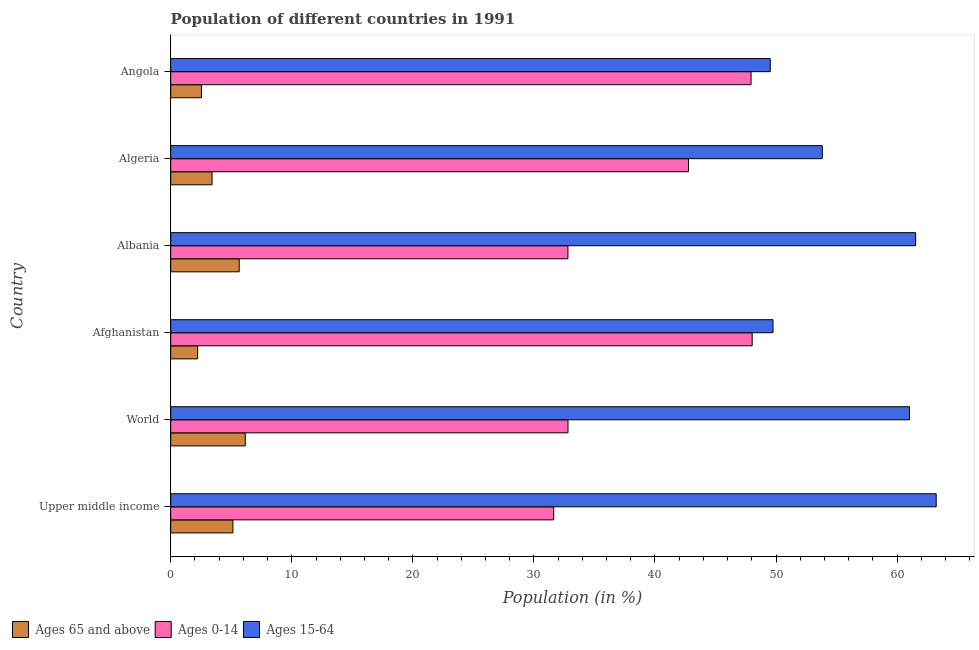How many groups of bars are there?
Provide a succinct answer. 6. Are the number of bars per tick equal to the number of legend labels?
Make the answer very short. Yes. Are the number of bars on each tick of the Y-axis equal?
Provide a succinct answer. Yes. How many bars are there on the 6th tick from the top?
Offer a very short reply. 3. How many bars are there on the 1st tick from the bottom?
Your answer should be very brief. 3. What is the label of the 2nd group of bars from the top?
Provide a succinct answer. Algeria. In how many cases, is the number of bars for a given country not equal to the number of legend labels?
Ensure brevity in your answer.  0. What is the percentage of population within the age-group 15-64 in Upper middle income?
Make the answer very short. 63.23. Across all countries, what is the maximum percentage of population within the age-group of 65 and above?
Ensure brevity in your answer.  6.16. Across all countries, what is the minimum percentage of population within the age-group 0-14?
Offer a very short reply. 31.63. In which country was the percentage of population within the age-group 15-64 maximum?
Offer a very short reply. Upper middle income. In which country was the percentage of population within the age-group 15-64 minimum?
Your answer should be compact. Angola. What is the total percentage of population within the age-group of 65 and above in the graph?
Give a very brief answer. 25.13. What is the difference between the percentage of population within the age-group 0-14 in Albania and that in Algeria?
Provide a succinct answer. -9.96. What is the difference between the percentage of population within the age-group of 65 and above in Angola and the percentage of population within the age-group 0-14 in Algeria?
Keep it short and to the point. -40.23. What is the average percentage of population within the age-group of 65 and above per country?
Keep it short and to the point. 4.19. What is the difference between the percentage of population within the age-group 0-14 and percentage of population within the age-group of 65 and above in Angola?
Offer a very short reply. 45.4. What is the ratio of the percentage of population within the age-group of 65 and above in Algeria to that in Angola?
Offer a terse response. 1.34. Is the percentage of population within the age-group 15-64 in Algeria less than that in Angola?
Offer a terse response. No. What is the difference between the highest and the second highest percentage of population within the age-group 0-14?
Offer a terse response. 0.09. What is the difference between the highest and the lowest percentage of population within the age-group 15-64?
Your answer should be very brief. 13.71. What does the 3rd bar from the top in Upper middle income represents?
Keep it short and to the point. Ages 65 and above. What does the 1st bar from the bottom in Upper middle income represents?
Provide a succinct answer. Ages 65 and above. How many bars are there?
Make the answer very short. 18. Are all the bars in the graph horizontal?
Your response must be concise. Yes. Are the values on the major ticks of X-axis written in scientific E-notation?
Provide a succinct answer. No. Does the graph contain any zero values?
Give a very brief answer. No. Does the graph contain grids?
Provide a succinct answer. No. How many legend labels are there?
Make the answer very short. 3. How are the legend labels stacked?
Your answer should be compact. Horizontal. What is the title of the graph?
Offer a very short reply. Population of different countries in 1991. What is the label or title of the X-axis?
Your answer should be compact. Population (in %). What is the Population (in %) in Ages 65 and above in Upper middle income?
Make the answer very short. 5.14. What is the Population (in %) in Ages 0-14 in Upper middle income?
Provide a short and direct response. 31.63. What is the Population (in %) in Ages 15-64 in Upper middle income?
Give a very brief answer. 63.23. What is the Population (in %) of Ages 65 and above in World?
Keep it short and to the point. 6.16. What is the Population (in %) of Ages 0-14 in World?
Offer a very short reply. 32.82. What is the Population (in %) of Ages 15-64 in World?
Your answer should be compact. 61.03. What is the Population (in %) of Ages 65 and above in Afghanistan?
Provide a succinct answer. 2.22. What is the Population (in %) of Ages 0-14 in Afghanistan?
Your response must be concise. 48.03. What is the Population (in %) in Ages 15-64 in Afghanistan?
Keep it short and to the point. 49.75. What is the Population (in %) of Ages 65 and above in Albania?
Offer a very short reply. 5.66. What is the Population (in %) in Ages 0-14 in Albania?
Ensure brevity in your answer.  32.81. What is the Population (in %) in Ages 15-64 in Albania?
Offer a very short reply. 61.53. What is the Population (in %) in Ages 65 and above in Algeria?
Provide a succinct answer. 3.41. What is the Population (in %) of Ages 0-14 in Algeria?
Ensure brevity in your answer.  42.77. What is the Population (in %) in Ages 15-64 in Algeria?
Offer a terse response. 53.82. What is the Population (in %) of Ages 65 and above in Angola?
Keep it short and to the point. 2.54. What is the Population (in %) of Ages 0-14 in Angola?
Give a very brief answer. 47.94. What is the Population (in %) in Ages 15-64 in Angola?
Ensure brevity in your answer.  49.52. Across all countries, what is the maximum Population (in %) of Ages 65 and above?
Offer a very short reply. 6.16. Across all countries, what is the maximum Population (in %) of Ages 0-14?
Offer a very short reply. 48.03. Across all countries, what is the maximum Population (in %) in Ages 15-64?
Your answer should be compact. 63.23. Across all countries, what is the minimum Population (in %) of Ages 65 and above?
Your response must be concise. 2.22. Across all countries, what is the minimum Population (in %) of Ages 0-14?
Keep it short and to the point. 31.63. Across all countries, what is the minimum Population (in %) of Ages 15-64?
Provide a succinct answer. 49.52. What is the total Population (in %) in Ages 65 and above in the graph?
Ensure brevity in your answer.  25.12. What is the total Population (in %) of Ages 0-14 in the graph?
Provide a short and direct response. 236. What is the total Population (in %) in Ages 15-64 in the graph?
Your answer should be very brief. 338.88. What is the difference between the Population (in %) in Ages 65 and above in Upper middle income and that in World?
Provide a short and direct response. -1.02. What is the difference between the Population (in %) in Ages 0-14 in Upper middle income and that in World?
Your answer should be very brief. -1.18. What is the difference between the Population (in %) of Ages 15-64 in Upper middle income and that in World?
Keep it short and to the point. 2.21. What is the difference between the Population (in %) in Ages 65 and above in Upper middle income and that in Afghanistan?
Give a very brief answer. 2.91. What is the difference between the Population (in %) of Ages 0-14 in Upper middle income and that in Afghanistan?
Your answer should be compact. -16.4. What is the difference between the Population (in %) of Ages 15-64 in Upper middle income and that in Afghanistan?
Ensure brevity in your answer.  13.48. What is the difference between the Population (in %) of Ages 65 and above in Upper middle income and that in Albania?
Provide a short and direct response. -0.52. What is the difference between the Population (in %) of Ages 0-14 in Upper middle income and that in Albania?
Keep it short and to the point. -1.18. What is the difference between the Population (in %) of Ages 15-64 in Upper middle income and that in Albania?
Ensure brevity in your answer.  1.7. What is the difference between the Population (in %) of Ages 65 and above in Upper middle income and that in Algeria?
Offer a very short reply. 1.72. What is the difference between the Population (in %) of Ages 0-14 in Upper middle income and that in Algeria?
Your answer should be compact. -11.13. What is the difference between the Population (in %) in Ages 15-64 in Upper middle income and that in Algeria?
Keep it short and to the point. 9.41. What is the difference between the Population (in %) of Ages 65 and above in Upper middle income and that in Angola?
Ensure brevity in your answer.  2.6. What is the difference between the Population (in %) of Ages 0-14 in Upper middle income and that in Angola?
Your answer should be compact. -16.3. What is the difference between the Population (in %) of Ages 15-64 in Upper middle income and that in Angola?
Your answer should be very brief. 13.71. What is the difference between the Population (in %) in Ages 65 and above in World and that in Afghanistan?
Your answer should be compact. 3.94. What is the difference between the Population (in %) in Ages 0-14 in World and that in Afghanistan?
Offer a terse response. -15.21. What is the difference between the Population (in %) of Ages 15-64 in World and that in Afghanistan?
Provide a short and direct response. 11.28. What is the difference between the Population (in %) of Ages 65 and above in World and that in Albania?
Your response must be concise. 0.5. What is the difference between the Population (in %) in Ages 0-14 in World and that in Albania?
Your answer should be very brief. 0. What is the difference between the Population (in %) in Ages 15-64 in World and that in Albania?
Your response must be concise. -0.51. What is the difference between the Population (in %) of Ages 65 and above in World and that in Algeria?
Make the answer very short. 2.74. What is the difference between the Population (in %) in Ages 0-14 in World and that in Algeria?
Ensure brevity in your answer.  -9.95. What is the difference between the Population (in %) of Ages 15-64 in World and that in Algeria?
Provide a succinct answer. 7.21. What is the difference between the Population (in %) of Ages 65 and above in World and that in Angola?
Keep it short and to the point. 3.62. What is the difference between the Population (in %) of Ages 0-14 in World and that in Angola?
Your answer should be compact. -15.12. What is the difference between the Population (in %) in Ages 15-64 in World and that in Angola?
Your answer should be very brief. 11.5. What is the difference between the Population (in %) of Ages 65 and above in Afghanistan and that in Albania?
Provide a succinct answer. -3.44. What is the difference between the Population (in %) in Ages 0-14 in Afghanistan and that in Albania?
Give a very brief answer. 15.22. What is the difference between the Population (in %) of Ages 15-64 in Afghanistan and that in Albania?
Your response must be concise. -11.78. What is the difference between the Population (in %) of Ages 65 and above in Afghanistan and that in Algeria?
Offer a very short reply. -1.19. What is the difference between the Population (in %) in Ages 0-14 in Afghanistan and that in Algeria?
Make the answer very short. 5.26. What is the difference between the Population (in %) of Ages 15-64 in Afghanistan and that in Algeria?
Make the answer very short. -4.07. What is the difference between the Population (in %) of Ages 65 and above in Afghanistan and that in Angola?
Your answer should be compact. -0.32. What is the difference between the Population (in %) in Ages 0-14 in Afghanistan and that in Angola?
Your answer should be very brief. 0.09. What is the difference between the Population (in %) of Ages 15-64 in Afghanistan and that in Angola?
Ensure brevity in your answer.  0.23. What is the difference between the Population (in %) of Ages 65 and above in Albania and that in Algeria?
Provide a succinct answer. 2.24. What is the difference between the Population (in %) of Ages 0-14 in Albania and that in Algeria?
Make the answer very short. -9.95. What is the difference between the Population (in %) of Ages 15-64 in Albania and that in Algeria?
Your answer should be compact. 7.71. What is the difference between the Population (in %) of Ages 65 and above in Albania and that in Angola?
Keep it short and to the point. 3.12. What is the difference between the Population (in %) of Ages 0-14 in Albania and that in Angola?
Provide a succinct answer. -15.13. What is the difference between the Population (in %) of Ages 15-64 in Albania and that in Angola?
Provide a succinct answer. 12.01. What is the difference between the Population (in %) of Ages 65 and above in Algeria and that in Angola?
Offer a terse response. 0.88. What is the difference between the Population (in %) in Ages 0-14 in Algeria and that in Angola?
Provide a short and direct response. -5.17. What is the difference between the Population (in %) in Ages 15-64 in Algeria and that in Angola?
Provide a succinct answer. 4.29. What is the difference between the Population (in %) in Ages 65 and above in Upper middle income and the Population (in %) in Ages 0-14 in World?
Offer a very short reply. -27.68. What is the difference between the Population (in %) in Ages 65 and above in Upper middle income and the Population (in %) in Ages 15-64 in World?
Offer a terse response. -55.89. What is the difference between the Population (in %) of Ages 0-14 in Upper middle income and the Population (in %) of Ages 15-64 in World?
Offer a terse response. -29.39. What is the difference between the Population (in %) in Ages 65 and above in Upper middle income and the Population (in %) in Ages 0-14 in Afghanistan?
Provide a succinct answer. -42.89. What is the difference between the Population (in %) in Ages 65 and above in Upper middle income and the Population (in %) in Ages 15-64 in Afghanistan?
Make the answer very short. -44.61. What is the difference between the Population (in %) of Ages 0-14 in Upper middle income and the Population (in %) of Ages 15-64 in Afghanistan?
Give a very brief answer. -18.12. What is the difference between the Population (in %) of Ages 65 and above in Upper middle income and the Population (in %) of Ages 0-14 in Albania?
Ensure brevity in your answer.  -27.68. What is the difference between the Population (in %) of Ages 65 and above in Upper middle income and the Population (in %) of Ages 15-64 in Albania?
Your answer should be very brief. -56.39. What is the difference between the Population (in %) of Ages 0-14 in Upper middle income and the Population (in %) of Ages 15-64 in Albania?
Your response must be concise. -29.9. What is the difference between the Population (in %) in Ages 65 and above in Upper middle income and the Population (in %) in Ages 0-14 in Algeria?
Your response must be concise. -37.63. What is the difference between the Population (in %) of Ages 65 and above in Upper middle income and the Population (in %) of Ages 15-64 in Algeria?
Provide a short and direct response. -48.68. What is the difference between the Population (in %) in Ages 0-14 in Upper middle income and the Population (in %) in Ages 15-64 in Algeria?
Give a very brief answer. -22.19. What is the difference between the Population (in %) in Ages 65 and above in Upper middle income and the Population (in %) in Ages 0-14 in Angola?
Provide a succinct answer. -42.8. What is the difference between the Population (in %) of Ages 65 and above in Upper middle income and the Population (in %) of Ages 15-64 in Angola?
Provide a short and direct response. -44.39. What is the difference between the Population (in %) of Ages 0-14 in Upper middle income and the Population (in %) of Ages 15-64 in Angola?
Keep it short and to the point. -17.89. What is the difference between the Population (in %) of Ages 65 and above in World and the Population (in %) of Ages 0-14 in Afghanistan?
Ensure brevity in your answer.  -41.87. What is the difference between the Population (in %) of Ages 65 and above in World and the Population (in %) of Ages 15-64 in Afghanistan?
Offer a terse response. -43.59. What is the difference between the Population (in %) in Ages 0-14 in World and the Population (in %) in Ages 15-64 in Afghanistan?
Your response must be concise. -16.93. What is the difference between the Population (in %) of Ages 65 and above in World and the Population (in %) of Ages 0-14 in Albania?
Your answer should be compact. -26.65. What is the difference between the Population (in %) in Ages 65 and above in World and the Population (in %) in Ages 15-64 in Albania?
Provide a short and direct response. -55.37. What is the difference between the Population (in %) in Ages 0-14 in World and the Population (in %) in Ages 15-64 in Albania?
Make the answer very short. -28.71. What is the difference between the Population (in %) of Ages 65 and above in World and the Population (in %) of Ages 0-14 in Algeria?
Your answer should be very brief. -36.61. What is the difference between the Population (in %) of Ages 65 and above in World and the Population (in %) of Ages 15-64 in Algeria?
Keep it short and to the point. -47.66. What is the difference between the Population (in %) of Ages 0-14 in World and the Population (in %) of Ages 15-64 in Algeria?
Your answer should be compact. -21. What is the difference between the Population (in %) of Ages 65 and above in World and the Population (in %) of Ages 0-14 in Angola?
Offer a terse response. -41.78. What is the difference between the Population (in %) in Ages 65 and above in World and the Population (in %) in Ages 15-64 in Angola?
Provide a succinct answer. -43.37. What is the difference between the Population (in %) in Ages 0-14 in World and the Population (in %) in Ages 15-64 in Angola?
Ensure brevity in your answer.  -16.71. What is the difference between the Population (in %) of Ages 65 and above in Afghanistan and the Population (in %) of Ages 0-14 in Albania?
Offer a very short reply. -30.59. What is the difference between the Population (in %) of Ages 65 and above in Afghanistan and the Population (in %) of Ages 15-64 in Albania?
Provide a short and direct response. -59.31. What is the difference between the Population (in %) in Ages 0-14 in Afghanistan and the Population (in %) in Ages 15-64 in Albania?
Your answer should be very brief. -13.5. What is the difference between the Population (in %) in Ages 65 and above in Afghanistan and the Population (in %) in Ages 0-14 in Algeria?
Keep it short and to the point. -40.55. What is the difference between the Population (in %) of Ages 65 and above in Afghanistan and the Population (in %) of Ages 15-64 in Algeria?
Make the answer very short. -51.6. What is the difference between the Population (in %) in Ages 0-14 in Afghanistan and the Population (in %) in Ages 15-64 in Algeria?
Provide a succinct answer. -5.79. What is the difference between the Population (in %) in Ages 65 and above in Afghanistan and the Population (in %) in Ages 0-14 in Angola?
Ensure brevity in your answer.  -45.72. What is the difference between the Population (in %) in Ages 65 and above in Afghanistan and the Population (in %) in Ages 15-64 in Angola?
Ensure brevity in your answer.  -47.3. What is the difference between the Population (in %) of Ages 0-14 in Afghanistan and the Population (in %) of Ages 15-64 in Angola?
Offer a very short reply. -1.49. What is the difference between the Population (in %) of Ages 65 and above in Albania and the Population (in %) of Ages 0-14 in Algeria?
Make the answer very short. -37.11. What is the difference between the Population (in %) of Ages 65 and above in Albania and the Population (in %) of Ages 15-64 in Algeria?
Offer a very short reply. -48.16. What is the difference between the Population (in %) in Ages 0-14 in Albania and the Population (in %) in Ages 15-64 in Algeria?
Your answer should be compact. -21.01. What is the difference between the Population (in %) of Ages 65 and above in Albania and the Population (in %) of Ages 0-14 in Angola?
Give a very brief answer. -42.28. What is the difference between the Population (in %) of Ages 65 and above in Albania and the Population (in %) of Ages 15-64 in Angola?
Offer a very short reply. -43.87. What is the difference between the Population (in %) of Ages 0-14 in Albania and the Population (in %) of Ages 15-64 in Angola?
Your answer should be compact. -16.71. What is the difference between the Population (in %) in Ages 65 and above in Algeria and the Population (in %) in Ages 0-14 in Angola?
Provide a short and direct response. -44.52. What is the difference between the Population (in %) of Ages 65 and above in Algeria and the Population (in %) of Ages 15-64 in Angola?
Make the answer very short. -46.11. What is the difference between the Population (in %) in Ages 0-14 in Algeria and the Population (in %) in Ages 15-64 in Angola?
Your answer should be compact. -6.76. What is the average Population (in %) of Ages 65 and above per country?
Provide a succinct answer. 4.19. What is the average Population (in %) in Ages 0-14 per country?
Give a very brief answer. 39.33. What is the average Population (in %) of Ages 15-64 per country?
Your answer should be very brief. 56.48. What is the difference between the Population (in %) of Ages 65 and above and Population (in %) of Ages 0-14 in Upper middle income?
Give a very brief answer. -26.5. What is the difference between the Population (in %) in Ages 65 and above and Population (in %) in Ages 15-64 in Upper middle income?
Offer a terse response. -58.09. What is the difference between the Population (in %) of Ages 0-14 and Population (in %) of Ages 15-64 in Upper middle income?
Offer a terse response. -31.6. What is the difference between the Population (in %) in Ages 65 and above and Population (in %) in Ages 0-14 in World?
Provide a succinct answer. -26.66. What is the difference between the Population (in %) in Ages 65 and above and Population (in %) in Ages 15-64 in World?
Ensure brevity in your answer.  -54.87. What is the difference between the Population (in %) of Ages 0-14 and Population (in %) of Ages 15-64 in World?
Your response must be concise. -28.21. What is the difference between the Population (in %) of Ages 65 and above and Population (in %) of Ages 0-14 in Afghanistan?
Offer a very short reply. -45.81. What is the difference between the Population (in %) of Ages 65 and above and Population (in %) of Ages 15-64 in Afghanistan?
Keep it short and to the point. -47.53. What is the difference between the Population (in %) in Ages 0-14 and Population (in %) in Ages 15-64 in Afghanistan?
Offer a terse response. -1.72. What is the difference between the Population (in %) of Ages 65 and above and Population (in %) of Ages 0-14 in Albania?
Offer a terse response. -27.16. What is the difference between the Population (in %) of Ages 65 and above and Population (in %) of Ages 15-64 in Albania?
Your answer should be compact. -55.87. What is the difference between the Population (in %) of Ages 0-14 and Population (in %) of Ages 15-64 in Albania?
Offer a terse response. -28.72. What is the difference between the Population (in %) in Ages 65 and above and Population (in %) in Ages 0-14 in Algeria?
Keep it short and to the point. -39.35. What is the difference between the Population (in %) in Ages 65 and above and Population (in %) in Ages 15-64 in Algeria?
Your response must be concise. -50.41. What is the difference between the Population (in %) of Ages 0-14 and Population (in %) of Ages 15-64 in Algeria?
Make the answer very short. -11.05. What is the difference between the Population (in %) of Ages 65 and above and Population (in %) of Ages 0-14 in Angola?
Ensure brevity in your answer.  -45.4. What is the difference between the Population (in %) in Ages 65 and above and Population (in %) in Ages 15-64 in Angola?
Offer a terse response. -46.99. What is the difference between the Population (in %) in Ages 0-14 and Population (in %) in Ages 15-64 in Angola?
Your answer should be very brief. -1.59. What is the ratio of the Population (in %) in Ages 65 and above in Upper middle income to that in World?
Keep it short and to the point. 0.83. What is the ratio of the Population (in %) in Ages 15-64 in Upper middle income to that in World?
Keep it short and to the point. 1.04. What is the ratio of the Population (in %) in Ages 65 and above in Upper middle income to that in Afghanistan?
Offer a very short reply. 2.31. What is the ratio of the Population (in %) in Ages 0-14 in Upper middle income to that in Afghanistan?
Offer a terse response. 0.66. What is the ratio of the Population (in %) of Ages 15-64 in Upper middle income to that in Afghanistan?
Ensure brevity in your answer.  1.27. What is the ratio of the Population (in %) in Ages 65 and above in Upper middle income to that in Albania?
Make the answer very short. 0.91. What is the ratio of the Population (in %) in Ages 0-14 in Upper middle income to that in Albania?
Ensure brevity in your answer.  0.96. What is the ratio of the Population (in %) in Ages 15-64 in Upper middle income to that in Albania?
Provide a succinct answer. 1.03. What is the ratio of the Population (in %) in Ages 65 and above in Upper middle income to that in Algeria?
Provide a short and direct response. 1.5. What is the ratio of the Population (in %) of Ages 0-14 in Upper middle income to that in Algeria?
Your answer should be compact. 0.74. What is the ratio of the Population (in %) of Ages 15-64 in Upper middle income to that in Algeria?
Your response must be concise. 1.17. What is the ratio of the Population (in %) of Ages 65 and above in Upper middle income to that in Angola?
Your response must be concise. 2.02. What is the ratio of the Population (in %) in Ages 0-14 in Upper middle income to that in Angola?
Offer a very short reply. 0.66. What is the ratio of the Population (in %) in Ages 15-64 in Upper middle income to that in Angola?
Keep it short and to the point. 1.28. What is the ratio of the Population (in %) of Ages 65 and above in World to that in Afghanistan?
Your answer should be very brief. 2.77. What is the ratio of the Population (in %) of Ages 0-14 in World to that in Afghanistan?
Your answer should be compact. 0.68. What is the ratio of the Population (in %) in Ages 15-64 in World to that in Afghanistan?
Provide a succinct answer. 1.23. What is the ratio of the Population (in %) of Ages 65 and above in World to that in Albania?
Your response must be concise. 1.09. What is the ratio of the Population (in %) in Ages 15-64 in World to that in Albania?
Offer a very short reply. 0.99. What is the ratio of the Population (in %) of Ages 65 and above in World to that in Algeria?
Give a very brief answer. 1.8. What is the ratio of the Population (in %) in Ages 0-14 in World to that in Algeria?
Make the answer very short. 0.77. What is the ratio of the Population (in %) of Ages 15-64 in World to that in Algeria?
Ensure brevity in your answer.  1.13. What is the ratio of the Population (in %) of Ages 65 and above in World to that in Angola?
Offer a very short reply. 2.43. What is the ratio of the Population (in %) in Ages 0-14 in World to that in Angola?
Keep it short and to the point. 0.68. What is the ratio of the Population (in %) in Ages 15-64 in World to that in Angola?
Your answer should be very brief. 1.23. What is the ratio of the Population (in %) in Ages 65 and above in Afghanistan to that in Albania?
Offer a terse response. 0.39. What is the ratio of the Population (in %) in Ages 0-14 in Afghanistan to that in Albania?
Give a very brief answer. 1.46. What is the ratio of the Population (in %) in Ages 15-64 in Afghanistan to that in Albania?
Ensure brevity in your answer.  0.81. What is the ratio of the Population (in %) in Ages 65 and above in Afghanistan to that in Algeria?
Provide a short and direct response. 0.65. What is the ratio of the Population (in %) of Ages 0-14 in Afghanistan to that in Algeria?
Offer a very short reply. 1.12. What is the ratio of the Population (in %) in Ages 15-64 in Afghanistan to that in Algeria?
Provide a succinct answer. 0.92. What is the ratio of the Population (in %) of Ages 65 and above in Afghanistan to that in Angola?
Ensure brevity in your answer.  0.88. What is the ratio of the Population (in %) in Ages 65 and above in Albania to that in Algeria?
Ensure brevity in your answer.  1.66. What is the ratio of the Population (in %) in Ages 0-14 in Albania to that in Algeria?
Your response must be concise. 0.77. What is the ratio of the Population (in %) of Ages 15-64 in Albania to that in Algeria?
Offer a very short reply. 1.14. What is the ratio of the Population (in %) in Ages 65 and above in Albania to that in Angola?
Ensure brevity in your answer.  2.23. What is the ratio of the Population (in %) of Ages 0-14 in Albania to that in Angola?
Provide a short and direct response. 0.68. What is the ratio of the Population (in %) of Ages 15-64 in Albania to that in Angola?
Offer a terse response. 1.24. What is the ratio of the Population (in %) in Ages 65 and above in Algeria to that in Angola?
Provide a succinct answer. 1.34. What is the ratio of the Population (in %) in Ages 0-14 in Algeria to that in Angola?
Your response must be concise. 0.89. What is the ratio of the Population (in %) of Ages 15-64 in Algeria to that in Angola?
Give a very brief answer. 1.09. What is the difference between the highest and the second highest Population (in %) of Ages 65 and above?
Provide a short and direct response. 0.5. What is the difference between the highest and the second highest Population (in %) of Ages 0-14?
Provide a short and direct response. 0.09. What is the difference between the highest and the second highest Population (in %) of Ages 15-64?
Provide a succinct answer. 1.7. What is the difference between the highest and the lowest Population (in %) of Ages 65 and above?
Give a very brief answer. 3.94. What is the difference between the highest and the lowest Population (in %) in Ages 0-14?
Offer a very short reply. 16.4. What is the difference between the highest and the lowest Population (in %) of Ages 15-64?
Give a very brief answer. 13.71. 